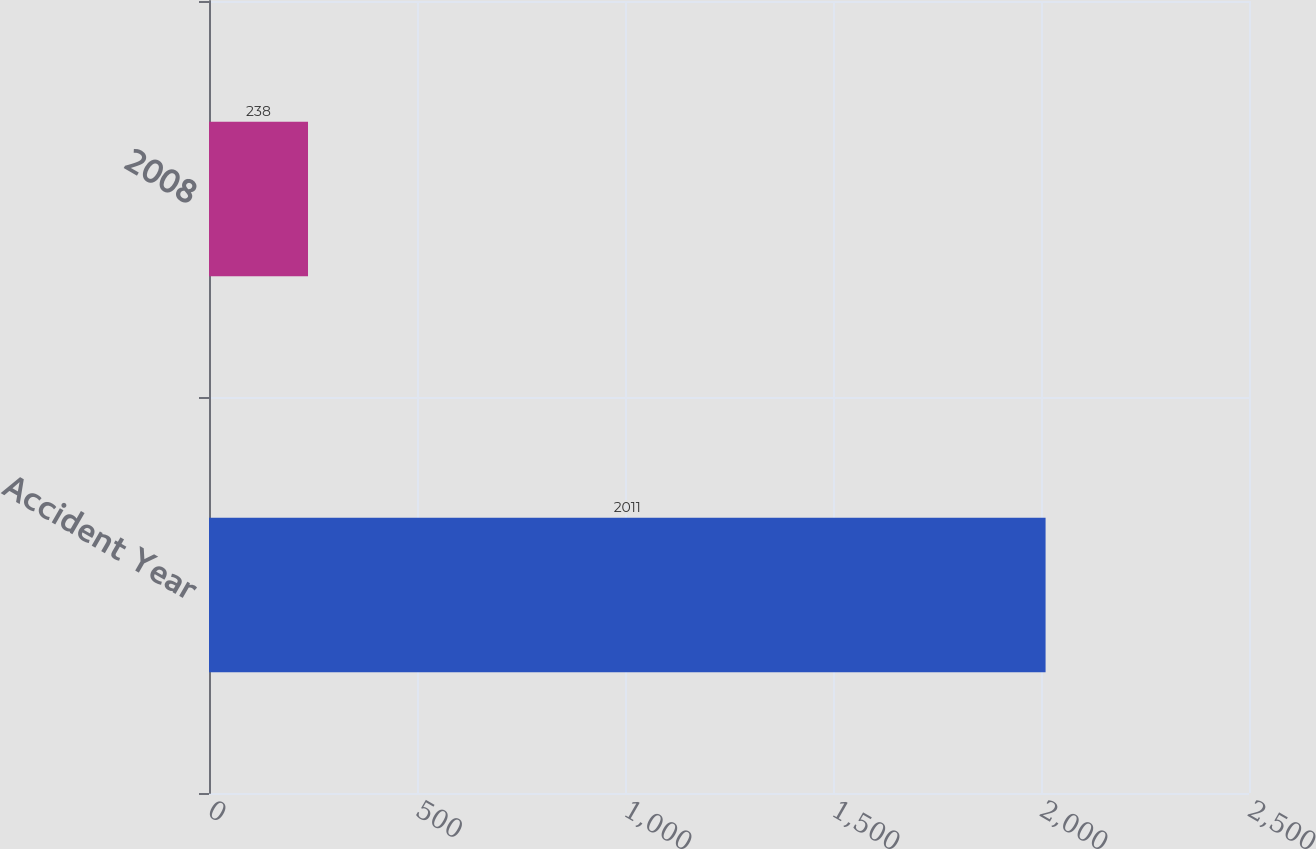Convert chart. <chart><loc_0><loc_0><loc_500><loc_500><bar_chart><fcel>Accident Year<fcel>2008<nl><fcel>2011<fcel>238<nl></chart> 